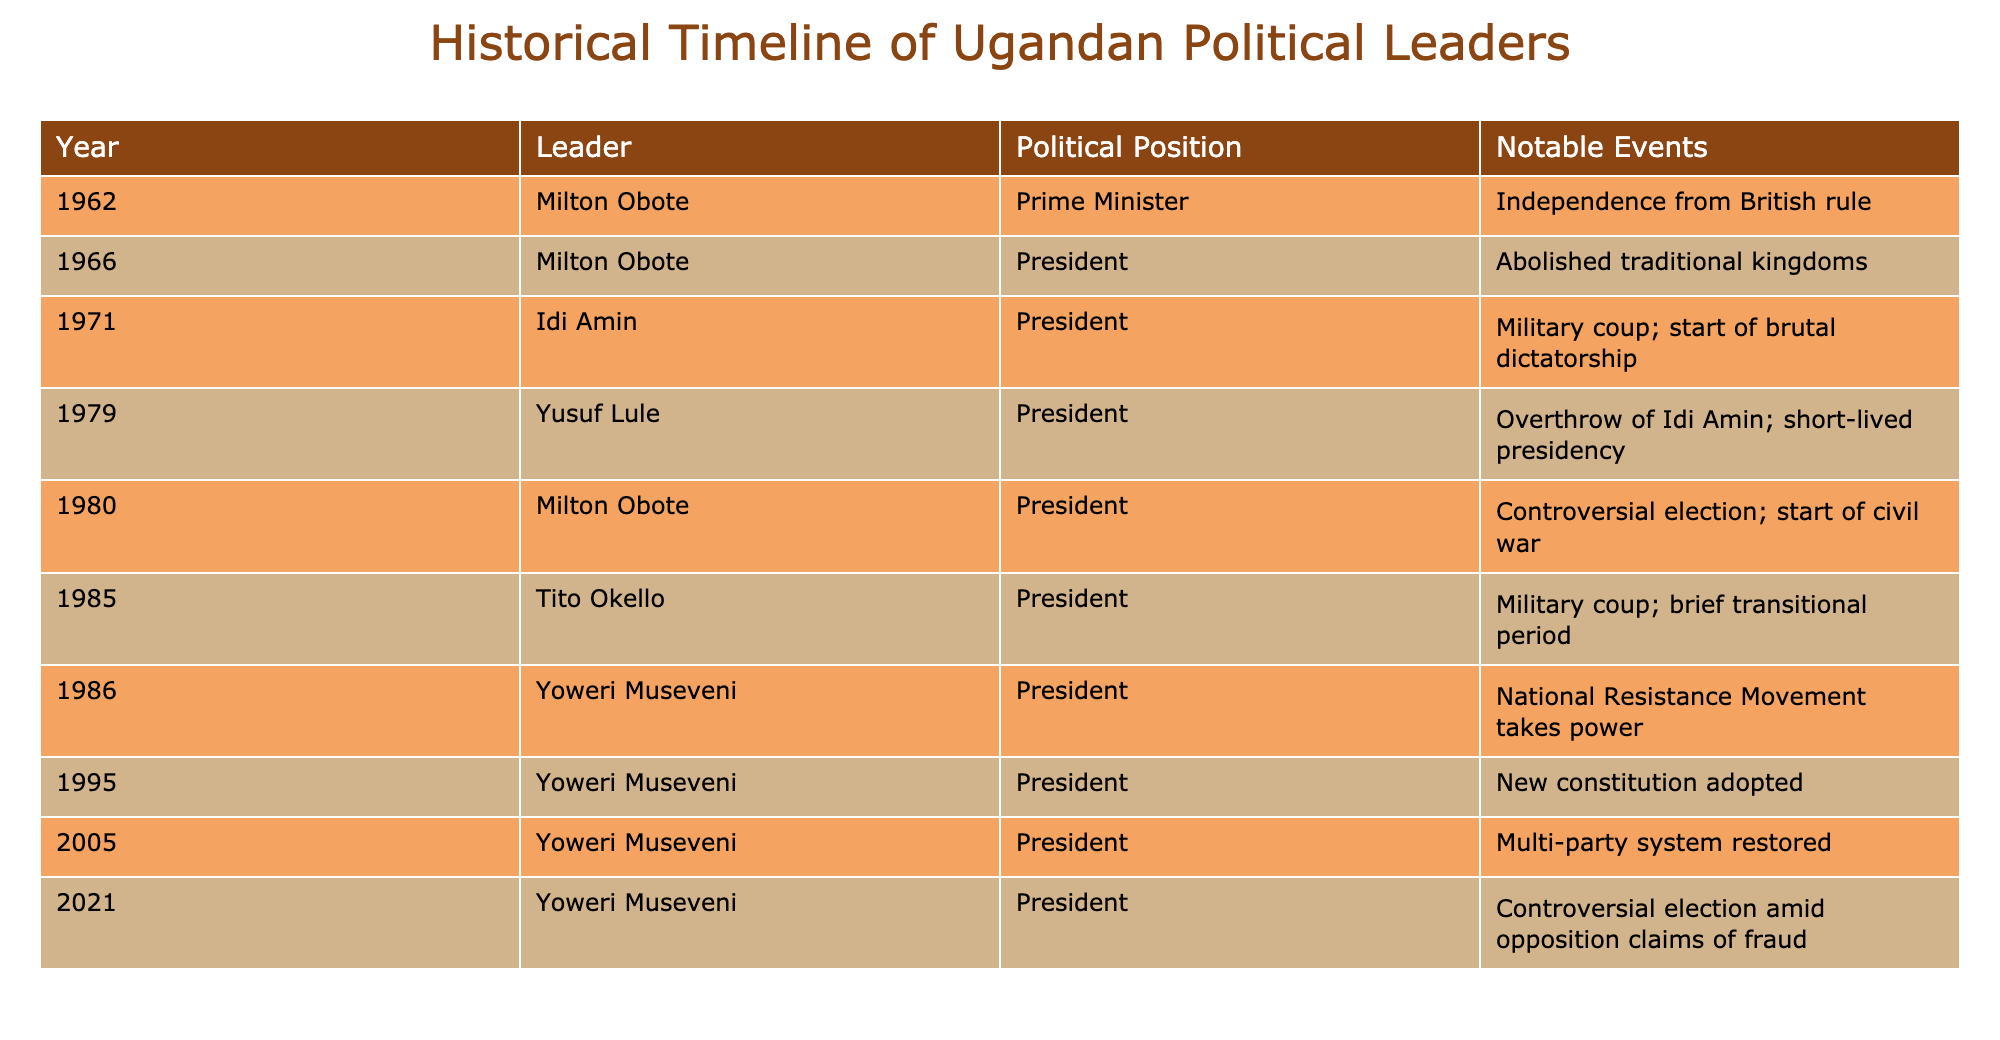What year did Milton Obote first become Prime Minister? The table indicates that Milton Obote became Prime Minister in 1962, which is the first entry related to his political career.
Answer: 1962 Who succeeded Idi Amin as President? According to the table, Yusuf Lule succeeded Idi Amin in 1979 after the overthrow of his regime.
Answer: Yusuf Lule How many leaders served as President between 1962 and 1985? The table lists 5 leaders who served as President during this period: Milton Obote (1966, 1980), Idi Amin (1971), Yusuf Lule (1979), and Tito Okello (1985). Therefore, the count is 5.
Answer: 5 Was there a new constitution adopted during Yoweri Museveni's presidency? Yes, the table states that a new constitution was adopted in 1995 during Yoweri Museveni's presidency.
Answer: Yes What are the years in which there were military coups in Uganda? By analyzing the table, there were military coups in the years of 1971 (Idi Amin's coup), 1985 (Tito Okello's coup), and 1980 (Milton Obote's controversial election linked to civil war). Thus, the years are 1971, 1980, and 1985.
Answer: 1971, 1980, 1985 How many notable events occurred during Yoweri Museveni's presidency as listed in the table? The table shows three notable events during Yoweri Museveni's presidency: he took power in 1986, adopted a new constitution in 1995, and restored the multi-party system in 2005, leading to a total of three events.
Answer: 3 Which leader had the longest uninterrupted term as President according to the table? Yoweri Museveni is listed as President from 1986 all the way to the 2021 elections without interruption, making his term the longest in the table.
Answer: Yoweri Museveni Were traditional kingdoms abolished before Yoweri Museveni's presidency? Yes, the table indicates that traditional kingdoms were abolished in 1966 under Milton Obote, prior to Yoweri Museveni taking office in 1986.
Answer: Yes How many leaders held political office for less than five years? The table shows that Yusuf Lule's presidency in 1979 and Tito Okello’s in 1985 were both short-term, which indicates that 2 leaders held political office for less than five years.
Answer: 2 